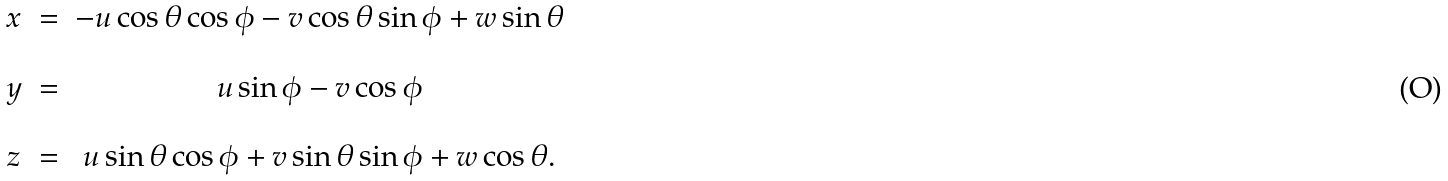<formula> <loc_0><loc_0><loc_500><loc_500>\begin{array} { c c c } x & = & - u \cos \theta \cos \phi - v \cos \theta \sin \phi + w \sin \theta \\ \\ y & = & u \sin \phi - v \cos \phi \\ \\ z & = & u \sin \theta \cos \phi + v \sin \theta \sin \phi + w \cos \theta . \end{array}</formula> 